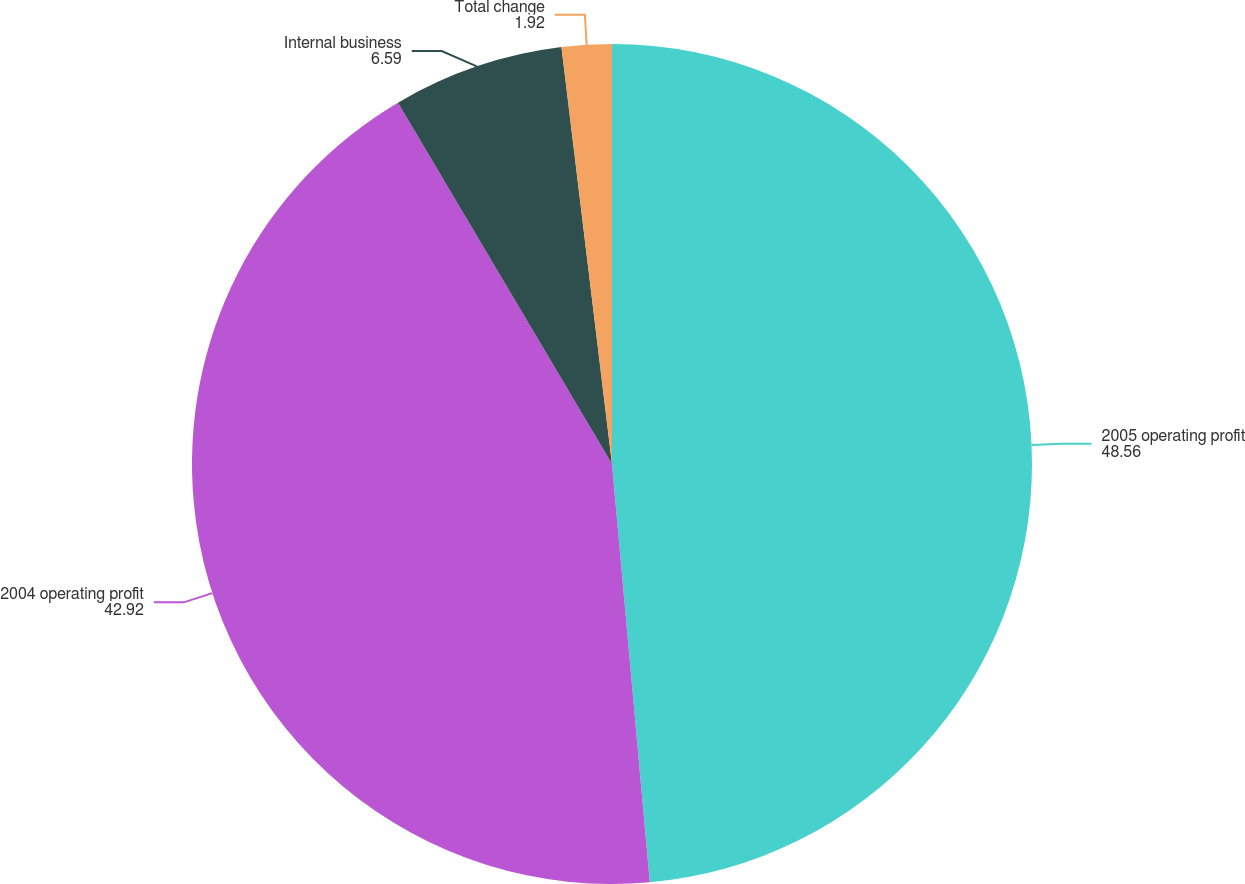Convert chart to OTSL. <chart><loc_0><loc_0><loc_500><loc_500><pie_chart><fcel>2005 operating profit<fcel>2004 operating profit<fcel>Internal business<fcel>Total change<nl><fcel>48.56%<fcel>42.92%<fcel>6.59%<fcel>1.92%<nl></chart> 